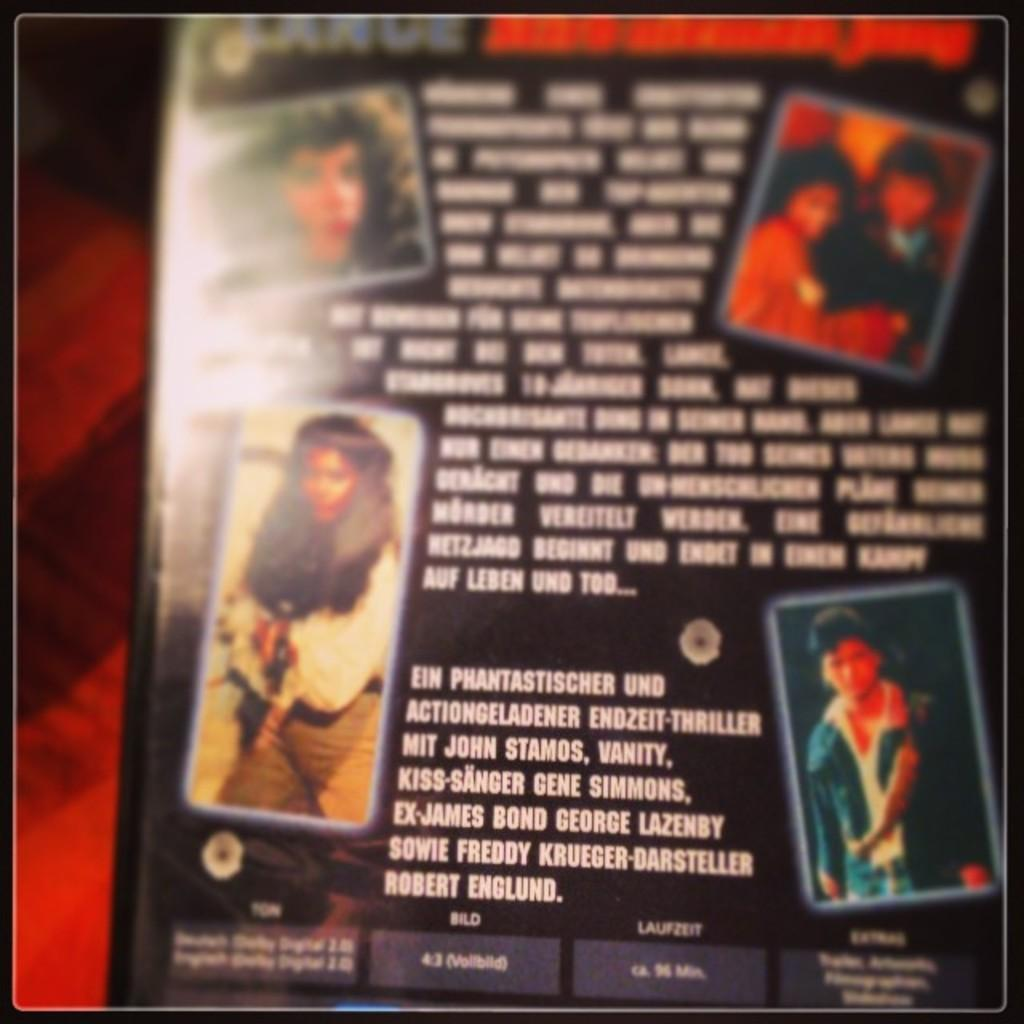What is the main subject of the image? The main subject of the image is a CD case. What is the color of the CD case? The CD case is black in color. What can be seen on the CD case besides its color? There are pictures and text on the CD case. What type of wool is used to create the ray on the CD case? There is no ray or wool present on the CD case; it only features pictures and text. 